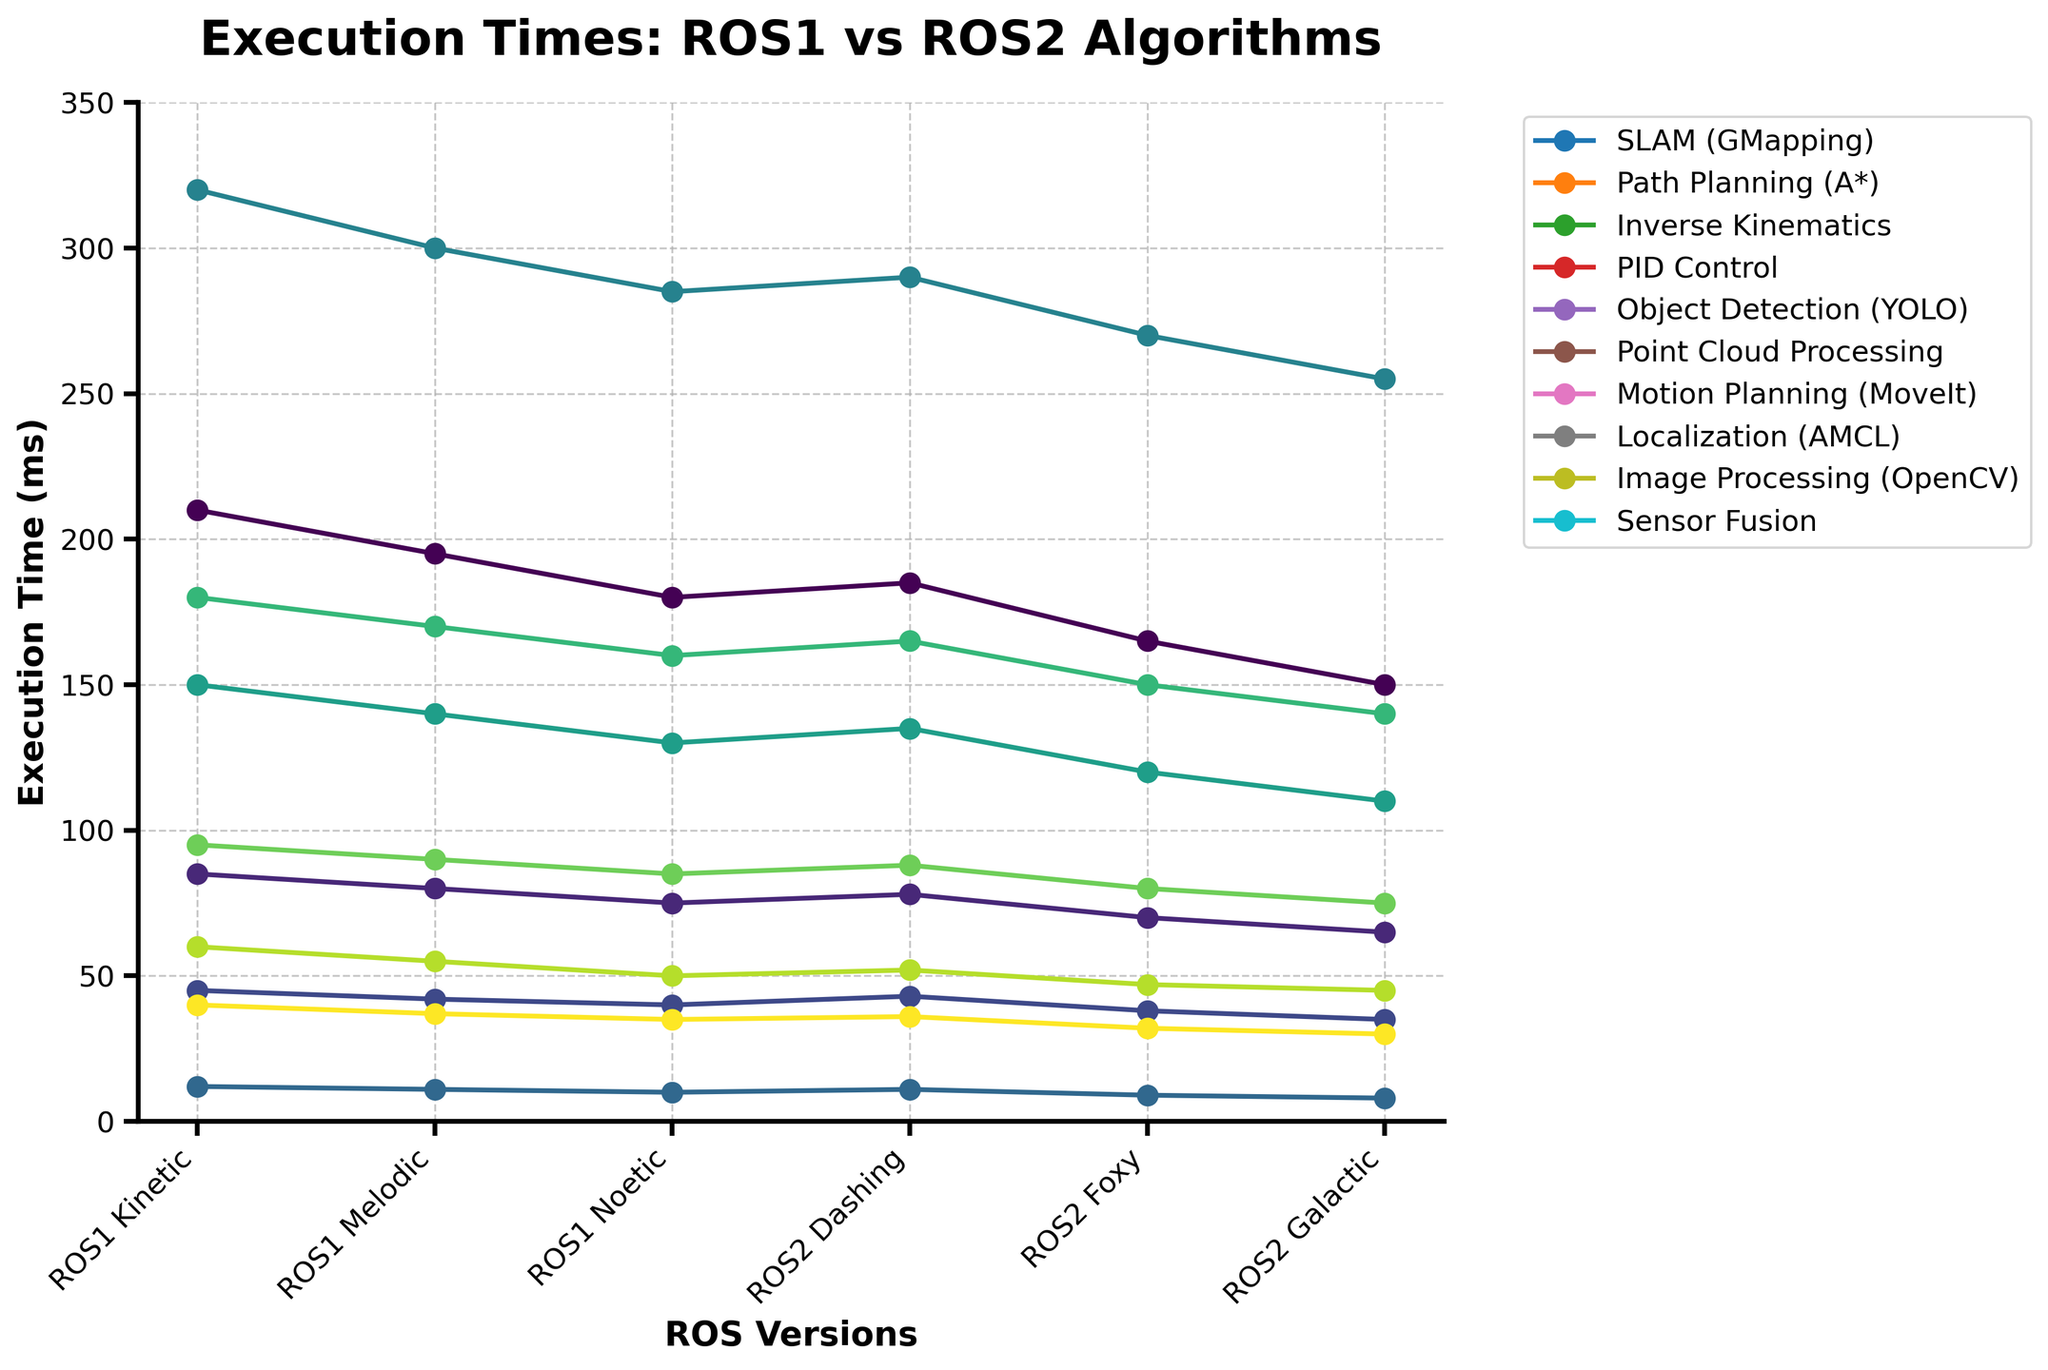What's the difference in execution time between ROS1 Kinetic and ROS2 Galactic for the SLAM (GMapping) algorithm? To find the difference, we subtract the execution time of ROS2 Galactic (150 ms) from ROS1 Kinetic (210 ms): 210 - 150 = 60.
Answer: 60 ms Which ROS version shows the most improvement in execution time for the PID Control algorithm compared to ROS1 Kinetic? The improvement is calculated by subtracting each ROS version's execution time from ROS1 Kinetic (12 ms). The greatest difference occurs in ROS2 Galactic: 12 - 8 = 4 ms.
Answer: ROS2 Galactic What is the average execution time for the Path Planning (A*) algorithm across all ROS versions? Sum the execution times across all versions (85 + 80 + 75 + 78 + 70 + 65) = 453, and divide by the number of versions (6): 453 / 6 = 75.5.
Answer: 75.5 ms Which algorithm has the largest variation in execution time between ROS1 Kinetic and ROS2 Galactic? The largest variation can be found by calculating the difference for each algorithm and comparing them. The Object Detection (YOLO) algorithm has the largest difference: 320 - 255 = 65 ms.
Answer: Object Detection (YOLO) How does the execution time trend for Point Cloud Processing compare between ROS1 and ROS2 versions? ROS1 times decrease from Kinetic (150) to Melodic (140) to Noetic (130), while in ROS2, they also steadily decrease from Dashing (135) to Foxy (120) to Galactic (110), showing a consistent downward trend in both ROS versions.
Answer: Consistent downward trend Among the provided algorithms, which one shows the least execution time across all ROS versions? By examining the lowest values for each algorithm, PID Control with ROS2 Galactic (8 ms) shows the least execution time.
Answer: PID Control (8 ms) For which algorithm does ROS2 Galactic have a faster execution time compared to all ROS1 versions? We look at each algorithm for ROS2 Galactic and see if it is faster than its corresponding times in ROS1 versions. For Inverse Kinematics, ROS2 Galactic (35 ms) is faster than all ROS1 implementations (45, 42, 40 ms).
Answer: Inverse Kinematics What's the ratio of the execution time of ROS2 Dashing to ROS1 Noetic for the Image Processing (OpenCV) algorithm? Divide the execution time of ROS2 Dashing (52 ms) by ROS1 Noetic (50 ms): 52 / 50 = 1.04.
Answer: 1.04 For the Localization (AMCL) algorithm, which version shows the smallest execution time, and what is that time? By comparing the times for Localization (AMCL) across all versions, ROS2 Galactic (75 ms) has the smallest execution time.
Answer: ROS2 Galactic, 75 ms 